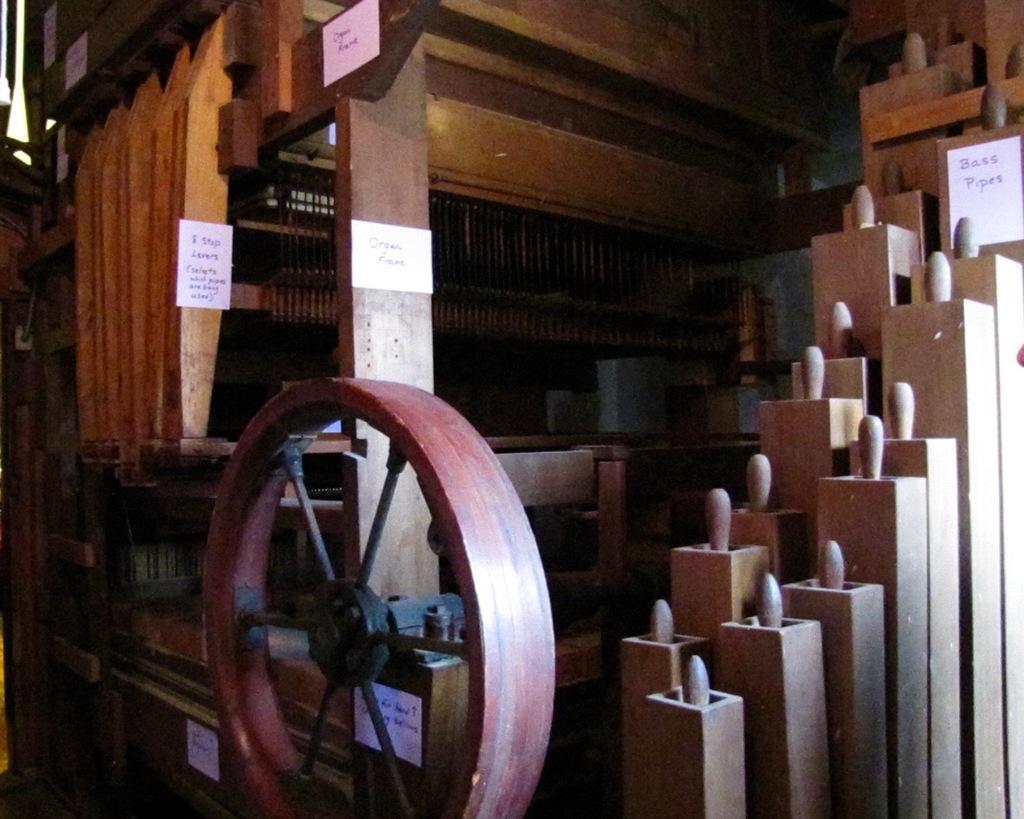What type of structure is depicted in the image? There is a wooden architecture in the image. What is attached to the wooden structure? Papers are attached to the wooden architecture. What can be found on the papers? There is text on the papers. What phase is the moon in during the signing of the agreement in the image? There is no mention of a moon or an agreement in the image, so it is not possible to answer that question. 